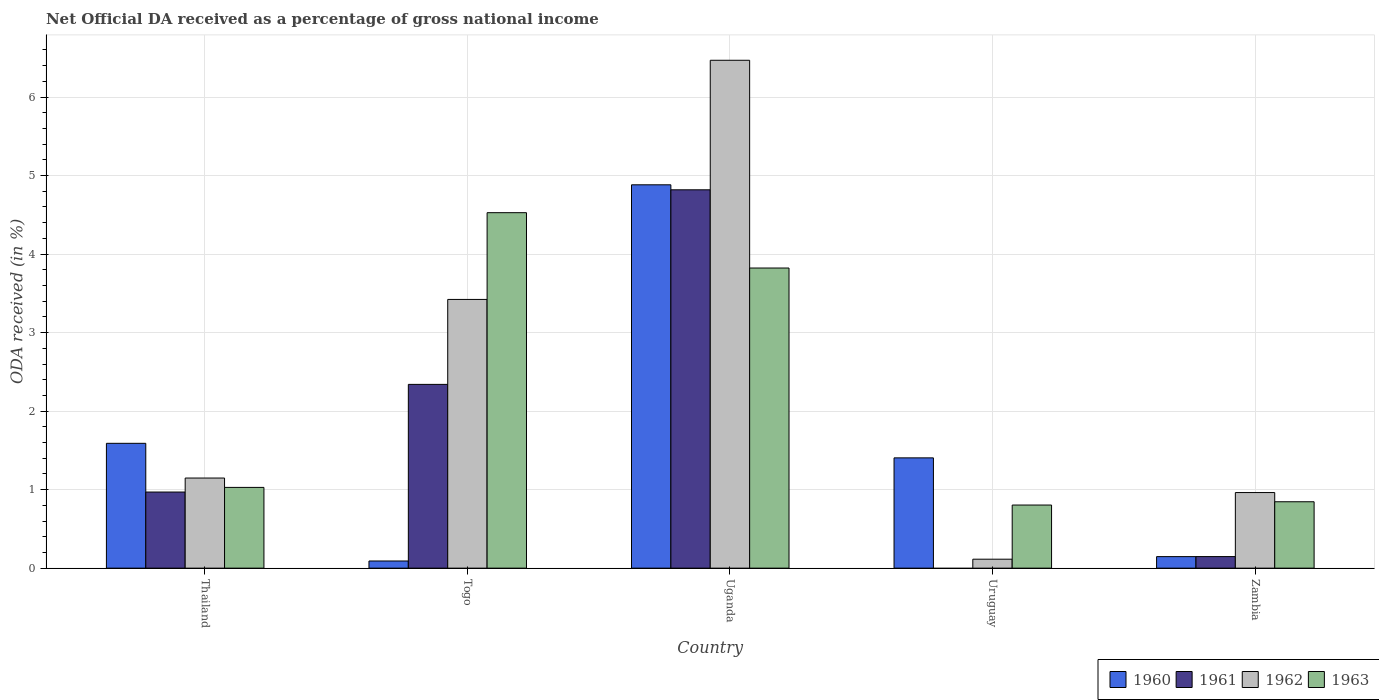How many different coloured bars are there?
Provide a short and direct response. 4. How many groups of bars are there?
Your answer should be very brief. 5. Are the number of bars on each tick of the X-axis equal?
Give a very brief answer. No. What is the label of the 5th group of bars from the left?
Give a very brief answer. Zambia. What is the net official DA received in 1963 in Uruguay?
Offer a very short reply. 0.8. Across all countries, what is the maximum net official DA received in 1961?
Your answer should be compact. 4.82. Across all countries, what is the minimum net official DA received in 1962?
Provide a short and direct response. 0.11. In which country was the net official DA received in 1960 maximum?
Keep it short and to the point. Uganda. What is the total net official DA received in 1963 in the graph?
Your answer should be very brief. 11.03. What is the difference between the net official DA received in 1963 in Togo and that in Uganda?
Your answer should be very brief. 0.71. What is the difference between the net official DA received in 1960 in Uganda and the net official DA received in 1962 in Thailand?
Offer a terse response. 3.73. What is the average net official DA received in 1960 per country?
Provide a short and direct response. 1.62. What is the difference between the net official DA received of/in 1960 and net official DA received of/in 1963 in Thailand?
Ensure brevity in your answer.  0.56. In how many countries, is the net official DA received in 1961 greater than 5.8 %?
Make the answer very short. 0. What is the ratio of the net official DA received in 1962 in Thailand to that in Uganda?
Your answer should be compact. 0.18. Is the net official DA received in 1962 in Thailand less than that in Uganda?
Offer a terse response. Yes. Is the difference between the net official DA received in 1960 in Togo and Uganda greater than the difference between the net official DA received in 1963 in Togo and Uganda?
Your response must be concise. No. What is the difference between the highest and the second highest net official DA received in 1960?
Offer a terse response. -3.29. What is the difference between the highest and the lowest net official DA received in 1963?
Offer a very short reply. 3.72. In how many countries, is the net official DA received in 1961 greater than the average net official DA received in 1961 taken over all countries?
Your response must be concise. 2. Is the sum of the net official DA received in 1960 in Thailand and Uganda greater than the maximum net official DA received in 1961 across all countries?
Provide a succinct answer. Yes. Are all the bars in the graph horizontal?
Your answer should be very brief. No. How many countries are there in the graph?
Offer a very short reply. 5. What is the difference between two consecutive major ticks on the Y-axis?
Provide a succinct answer. 1. Are the values on the major ticks of Y-axis written in scientific E-notation?
Provide a succinct answer. No. Does the graph contain grids?
Provide a short and direct response. Yes. How many legend labels are there?
Provide a succinct answer. 4. What is the title of the graph?
Keep it short and to the point. Net Official DA received as a percentage of gross national income. What is the label or title of the Y-axis?
Provide a short and direct response. ODA received (in %). What is the ODA received (in %) in 1960 in Thailand?
Provide a short and direct response. 1.59. What is the ODA received (in %) in 1961 in Thailand?
Offer a terse response. 0.97. What is the ODA received (in %) of 1962 in Thailand?
Offer a very short reply. 1.15. What is the ODA received (in %) in 1963 in Thailand?
Give a very brief answer. 1.03. What is the ODA received (in %) of 1960 in Togo?
Ensure brevity in your answer.  0.09. What is the ODA received (in %) of 1961 in Togo?
Your answer should be very brief. 2.34. What is the ODA received (in %) of 1962 in Togo?
Keep it short and to the point. 3.42. What is the ODA received (in %) of 1963 in Togo?
Give a very brief answer. 4.53. What is the ODA received (in %) of 1960 in Uganda?
Your answer should be compact. 4.88. What is the ODA received (in %) in 1961 in Uganda?
Provide a short and direct response. 4.82. What is the ODA received (in %) of 1962 in Uganda?
Offer a very short reply. 6.47. What is the ODA received (in %) in 1963 in Uganda?
Your answer should be very brief. 3.82. What is the ODA received (in %) in 1960 in Uruguay?
Your response must be concise. 1.4. What is the ODA received (in %) of 1961 in Uruguay?
Make the answer very short. 0. What is the ODA received (in %) of 1962 in Uruguay?
Ensure brevity in your answer.  0.11. What is the ODA received (in %) in 1963 in Uruguay?
Offer a terse response. 0.8. What is the ODA received (in %) in 1960 in Zambia?
Your answer should be compact. 0.15. What is the ODA received (in %) in 1961 in Zambia?
Your response must be concise. 0.15. What is the ODA received (in %) in 1962 in Zambia?
Ensure brevity in your answer.  0.96. What is the ODA received (in %) in 1963 in Zambia?
Offer a very short reply. 0.85. Across all countries, what is the maximum ODA received (in %) of 1960?
Provide a succinct answer. 4.88. Across all countries, what is the maximum ODA received (in %) in 1961?
Your answer should be compact. 4.82. Across all countries, what is the maximum ODA received (in %) in 1962?
Ensure brevity in your answer.  6.47. Across all countries, what is the maximum ODA received (in %) of 1963?
Provide a short and direct response. 4.53. Across all countries, what is the minimum ODA received (in %) in 1960?
Offer a terse response. 0.09. Across all countries, what is the minimum ODA received (in %) of 1962?
Offer a terse response. 0.11. Across all countries, what is the minimum ODA received (in %) in 1963?
Your answer should be compact. 0.8. What is the total ODA received (in %) of 1960 in the graph?
Keep it short and to the point. 8.12. What is the total ODA received (in %) of 1961 in the graph?
Your response must be concise. 8.28. What is the total ODA received (in %) of 1962 in the graph?
Ensure brevity in your answer.  12.12. What is the total ODA received (in %) in 1963 in the graph?
Ensure brevity in your answer.  11.03. What is the difference between the ODA received (in %) in 1960 in Thailand and that in Togo?
Your answer should be very brief. 1.5. What is the difference between the ODA received (in %) of 1961 in Thailand and that in Togo?
Keep it short and to the point. -1.37. What is the difference between the ODA received (in %) of 1962 in Thailand and that in Togo?
Provide a succinct answer. -2.27. What is the difference between the ODA received (in %) in 1963 in Thailand and that in Togo?
Provide a short and direct response. -3.5. What is the difference between the ODA received (in %) in 1960 in Thailand and that in Uganda?
Keep it short and to the point. -3.29. What is the difference between the ODA received (in %) in 1961 in Thailand and that in Uganda?
Offer a terse response. -3.85. What is the difference between the ODA received (in %) in 1962 in Thailand and that in Uganda?
Make the answer very short. -5.32. What is the difference between the ODA received (in %) in 1963 in Thailand and that in Uganda?
Provide a succinct answer. -2.79. What is the difference between the ODA received (in %) of 1960 in Thailand and that in Uruguay?
Your answer should be very brief. 0.19. What is the difference between the ODA received (in %) of 1962 in Thailand and that in Uruguay?
Your response must be concise. 1.03. What is the difference between the ODA received (in %) of 1963 in Thailand and that in Uruguay?
Make the answer very short. 0.22. What is the difference between the ODA received (in %) of 1960 in Thailand and that in Zambia?
Your answer should be compact. 1.44. What is the difference between the ODA received (in %) in 1961 in Thailand and that in Zambia?
Make the answer very short. 0.82. What is the difference between the ODA received (in %) of 1962 in Thailand and that in Zambia?
Make the answer very short. 0.18. What is the difference between the ODA received (in %) in 1963 in Thailand and that in Zambia?
Your answer should be compact. 0.18. What is the difference between the ODA received (in %) of 1960 in Togo and that in Uganda?
Your answer should be compact. -4.79. What is the difference between the ODA received (in %) in 1961 in Togo and that in Uganda?
Your answer should be compact. -2.48. What is the difference between the ODA received (in %) in 1962 in Togo and that in Uganda?
Offer a very short reply. -3.05. What is the difference between the ODA received (in %) in 1963 in Togo and that in Uganda?
Keep it short and to the point. 0.7. What is the difference between the ODA received (in %) in 1960 in Togo and that in Uruguay?
Your response must be concise. -1.31. What is the difference between the ODA received (in %) of 1962 in Togo and that in Uruguay?
Provide a short and direct response. 3.31. What is the difference between the ODA received (in %) of 1963 in Togo and that in Uruguay?
Your answer should be compact. 3.72. What is the difference between the ODA received (in %) in 1960 in Togo and that in Zambia?
Your answer should be compact. -0.06. What is the difference between the ODA received (in %) in 1961 in Togo and that in Zambia?
Keep it short and to the point. 2.19. What is the difference between the ODA received (in %) of 1962 in Togo and that in Zambia?
Your answer should be very brief. 2.46. What is the difference between the ODA received (in %) of 1963 in Togo and that in Zambia?
Your response must be concise. 3.68. What is the difference between the ODA received (in %) in 1960 in Uganda and that in Uruguay?
Give a very brief answer. 3.48. What is the difference between the ODA received (in %) in 1962 in Uganda and that in Uruguay?
Offer a very short reply. 6.35. What is the difference between the ODA received (in %) of 1963 in Uganda and that in Uruguay?
Ensure brevity in your answer.  3.02. What is the difference between the ODA received (in %) in 1960 in Uganda and that in Zambia?
Give a very brief answer. 4.74. What is the difference between the ODA received (in %) in 1961 in Uganda and that in Zambia?
Offer a very short reply. 4.67. What is the difference between the ODA received (in %) of 1962 in Uganda and that in Zambia?
Keep it short and to the point. 5.51. What is the difference between the ODA received (in %) of 1963 in Uganda and that in Zambia?
Provide a short and direct response. 2.98. What is the difference between the ODA received (in %) in 1960 in Uruguay and that in Zambia?
Make the answer very short. 1.26. What is the difference between the ODA received (in %) of 1962 in Uruguay and that in Zambia?
Make the answer very short. -0.85. What is the difference between the ODA received (in %) of 1963 in Uruguay and that in Zambia?
Your answer should be very brief. -0.04. What is the difference between the ODA received (in %) in 1960 in Thailand and the ODA received (in %) in 1961 in Togo?
Offer a very short reply. -0.75. What is the difference between the ODA received (in %) in 1960 in Thailand and the ODA received (in %) in 1962 in Togo?
Offer a terse response. -1.83. What is the difference between the ODA received (in %) of 1960 in Thailand and the ODA received (in %) of 1963 in Togo?
Make the answer very short. -2.94. What is the difference between the ODA received (in %) in 1961 in Thailand and the ODA received (in %) in 1962 in Togo?
Your answer should be compact. -2.45. What is the difference between the ODA received (in %) of 1961 in Thailand and the ODA received (in %) of 1963 in Togo?
Your response must be concise. -3.56. What is the difference between the ODA received (in %) of 1962 in Thailand and the ODA received (in %) of 1963 in Togo?
Offer a terse response. -3.38. What is the difference between the ODA received (in %) of 1960 in Thailand and the ODA received (in %) of 1961 in Uganda?
Make the answer very short. -3.23. What is the difference between the ODA received (in %) of 1960 in Thailand and the ODA received (in %) of 1962 in Uganda?
Give a very brief answer. -4.88. What is the difference between the ODA received (in %) in 1960 in Thailand and the ODA received (in %) in 1963 in Uganda?
Keep it short and to the point. -2.23. What is the difference between the ODA received (in %) in 1961 in Thailand and the ODA received (in %) in 1962 in Uganda?
Ensure brevity in your answer.  -5.5. What is the difference between the ODA received (in %) in 1961 in Thailand and the ODA received (in %) in 1963 in Uganda?
Provide a short and direct response. -2.85. What is the difference between the ODA received (in %) in 1962 in Thailand and the ODA received (in %) in 1963 in Uganda?
Offer a terse response. -2.67. What is the difference between the ODA received (in %) of 1960 in Thailand and the ODA received (in %) of 1962 in Uruguay?
Your answer should be very brief. 1.48. What is the difference between the ODA received (in %) in 1960 in Thailand and the ODA received (in %) in 1963 in Uruguay?
Ensure brevity in your answer.  0.79. What is the difference between the ODA received (in %) in 1961 in Thailand and the ODA received (in %) in 1962 in Uruguay?
Provide a succinct answer. 0.86. What is the difference between the ODA received (in %) in 1961 in Thailand and the ODA received (in %) in 1963 in Uruguay?
Ensure brevity in your answer.  0.17. What is the difference between the ODA received (in %) in 1962 in Thailand and the ODA received (in %) in 1963 in Uruguay?
Provide a succinct answer. 0.34. What is the difference between the ODA received (in %) in 1960 in Thailand and the ODA received (in %) in 1961 in Zambia?
Offer a very short reply. 1.44. What is the difference between the ODA received (in %) of 1960 in Thailand and the ODA received (in %) of 1962 in Zambia?
Give a very brief answer. 0.63. What is the difference between the ODA received (in %) of 1960 in Thailand and the ODA received (in %) of 1963 in Zambia?
Offer a terse response. 0.74. What is the difference between the ODA received (in %) of 1961 in Thailand and the ODA received (in %) of 1962 in Zambia?
Your response must be concise. 0.01. What is the difference between the ODA received (in %) in 1961 in Thailand and the ODA received (in %) in 1963 in Zambia?
Give a very brief answer. 0.12. What is the difference between the ODA received (in %) in 1962 in Thailand and the ODA received (in %) in 1963 in Zambia?
Offer a terse response. 0.3. What is the difference between the ODA received (in %) of 1960 in Togo and the ODA received (in %) of 1961 in Uganda?
Offer a terse response. -4.73. What is the difference between the ODA received (in %) in 1960 in Togo and the ODA received (in %) in 1962 in Uganda?
Give a very brief answer. -6.38. What is the difference between the ODA received (in %) of 1960 in Togo and the ODA received (in %) of 1963 in Uganda?
Provide a succinct answer. -3.73. What is the difference between the ODA received (in %) of 1961 in Togo and the ODA received (in %) of 1962 in Uganda?
Your answer should be compact. -4.13. What is the difference between the ODA received (in %) of 1961 in Togo and the ODA received (in %) of 1963 in Uganda?
Provide a short and direct response. -1.48. What is the difference between the ODA received (in %) of 1962 in Togo and the ODA received (in %) of 1963 in Uganda?
Ensure brevity in your answer.  -0.4. What is the difference between the ODA received (in %) of 1960 in Togo and the ODA received (in %) of 1962 in Uruguay?
Keep it short and to the point. -0.02. What is the difference between the ODA received (in %) in 1960 in Togo and the ODA received (in %) in 1963 in Uruguay?
Provide a succinct answer. -0.71. What is the difference between the ODA received (in %) of 1961 in Togo and the ODA received (in %) of 1962 in Uruguay?
Give a very brief answer. 2.23. What is the difference between the ODA received (in %) in 1961 in Togo and the ODA received (in %) in 1963 in Uruguay?
Give a very brief answer. 1.54. What is the difference between the ODA received (in %) of 1962 in Togo and the ODA received (in %) of 1963 in Uruguay?
Your answer should be compact. 2.62. What is the difference between the ODA received (in %) in 1960 in Togo and the ODA received (in %) in 1961 in Zambia?
Make the answer very short. -0.06. What is the difference between the ODA received (in %) of 1960 in Togo and the ODA received (in %) of 1962 in Zambia?
Give a very brief answer. -0.87. What is the difference between the ODA received (in %) of 1960 in Togo and the ODA received (in %) of 1963 in Zambia?
Your answer should be very brief. -0.75. What is the difference between the ODA received (in %) in 1961 in Togo and the ODA received (in %) in 1962 in Zambia?
Your response must be concise. 1.38. What is the difference between the ODA received (in %) of 1961 in Togo and the ODA received (in %) of 1963 in Zambia?
Offer a terse response. 1.5. What is the difference between the ODA received (in %) in 1962 in Togo and the ODA received (in %) in 1963 in Zambia?
Your answer should be very brief. 2.58. What is the difference between the ODA received (in %) in 1960 in Uganda and the ODA received (in %) in 1962 in Uruguay?
Offer a terse response. 4.77. What is the difference between the ODA received (in %) in 1960 in Uganda and the ODA received (in %) in 1963 in Uruguay?
Keep it short and to the point. 4.08. What is the difference between the ODA received (in %) of 1961 in Uganda and the ODA received (in %) of 1962 in Uruguay?
Give a very brief answer. 4.7. What is the difference between the ODA received (in %) of 1961 in Uganda and the ODA received (in %) of 1963 in Uruguay?
Provide a short and direct response. 4.01. What is the difference between the ODA received (in %) of 1962 in Uganda and the ODA received (in %) of 1963 in Uruguay?
Keep it short and to the point. 5.66. What is the difference between the ODA received (in %) in 1960 in Uganda and the ODA received (in %) in 1961 in Zambia?
Ensure brevity in your answer.  4.74. What is the difference between the ODA received (in %) in 1960 in Uganda and the ODA received (in %) in 1962 in Zambia?
Provide a succinct answer. 3.92. What is the difference between the ODA received (in %) of 1960 in Uganda and the ODA received (in %) of 1963 in Zambia?
Ensure brevity in your answer.  4.04. What is the difference between the ODA received (in %) in 1961 in Uganda and the ODA received (in %) in 1962 in Zambia?
Keep it short and to the point. 3.86. What is the difference between the ODA received (in %) of 1961 in Uganda and the ODA received (in %) of 1963 in Zambia?
Give a very brief answer. 3.97. What is the difference between the ODA received (in %) of 1962 in Uganda and the ODA received (in %) of 1963 in Zambia?
Ensure brevity in your answer.  5.62. What is the difference between the ODA received (in %) of 1960 in Uruguay and the ODA received (in %) of 1961 in Zambia?
Provide a succinct answer. 1.26. What is the difference between the ODA received (in %) in 1960 in Uruguay and the ODA received (in %) in 1962 in Zambia?
Your answer should be very brief. 0.44. What is the difference between the ODA received (in %) of 1960 in Uruguay and the ODA received (in %) of 1963 in Zambia?
Ensure brevity in your answer.  0.56. What is the difference between the ODA received (in %) in 1962 in Uruguay and the ODA received (in %) in 1963 in Zambia?
Your response must be concise. -0.73. What is the average ODA received (in %) in 1960 per country?
Give a very brief answer. 1.62. What is the average ODA received (in %) of 1961 per country?
Your response must be concise. 1.66. What is the average ODA received (in %) of 1962 per country?
Give a very brief answer. 2.42. What is the average ODA received (in %) in 1963 per country?
Your response must be concise. 2.21. What is the difference between the ODA received (in %) in 1960 and ODA received (in %) in 1961 in Thailand?
Offer a terse response. 0.62. What is the difference between the ODA received (in %) of 1960 and ODA received (in %) of 1962 in Thailand?
Make the answer very short. 0.44. What is the difference between the ODA received (in %) of 1960 and ODA received (in %) of 1963 in Thailand?
Ensure brevity in your answer.  0.56. What is the difference between the ODA received (in %) of 1961 and ODA received (in %) of 1962 in Thailand?
Ensure brevity in your answer.  -0.18. What is the difference between the ODA received (in %) in 1961 and ODA received (in %) in 1963 in Thailand?
Offer a terse response. -0.06. What is the difference between the ODA received (in %) of 1962 and ODA received (in %) of 1963 in Thailand?
Offer a very short reply. 0.12. What is the difference between the ODA received (in %) in 1960 and ODA received (in %) in 1961 in Togo?
Provide a succinct answer. -2.25. What is the difference between the ODA received (in %) of 1960 and ODA received (in %) of 1962 in Togo?
Your answer should be compact. -3.33. What is the difference between the ODA received (in %) of 1960 and ODA received (in %) of 1963 in Togo?
Provide a succinct answer. -4.44. What is the difference between the ODA received (in %) in 1961 and ODA received (in %) in 1962 in Togo?
Your answer should be compact. -1.08. What is the difference between the ODA received (in %) in 1961 and ODA received (in %) in 1963 in Togo?
Your response must be concise. -2.19. What is the difference between the ODA received (in %) in 1962 and ODA received (in %) in 1963 in Togo?
Provide a short and direct response. -1.1. What is the difference between the ODA received (in %) of 1960 and ODA received (in %) of 1961 in Uganda?
Offer a very short reply. 0.06. What is the difference between the ODA received (in %) of 1960 and ODA received (in %) of 1962 in Uganda?
Your answer should be very brief. -1.59. What is the difference between the ODA received (in %) of 1960 and ODA received (in %) of 1963 in Uganda?
Your answer should be very brief. 1.06. What is the difference between the ODA received (in %) in 1961 and ODA received (in %) in 1962 in Uganda?
Your answer should be compact. -1.65. What is the difference between the ODA received (in %) in 1961 and ODA received (in %) in 1963 in Uganda?
Ensure brevity in your answer.  1. What is the difference between the ODA received (in %) of 1962 and ODA received (in %) of 1963 in Uganda?
Provide a succinct answer. 2.65. What is the difference between the ODA received (in %) of 1960 and ODA received (in %) of 1962 in Uruguay?
Provide a short and direct response. 1.29. What is the difference between the ODA received (in %) in 1960 and ODA received (in %) in 1963 in Uruguay?
Your answer should be compact. 0.6. What is the difference between the ODA received (in %) in 1962 and ODA received (in %) in 1963 in Uruguay?
Offer a terse response. -0.69. What is the difference between the ODA received (in %) of 1960 and ODA received (in %) of 1961 in Zambia?
Your answer should be very brief. -0. What is the difference between the ODA received (in %) in 1960 and ODA received (in %) in 1962 in Zambia?
Ensure brevity in your answer.  -0.82. What is the difference between the ODA received (in %) of 1960 and ODA received (in %) of 1963 in Zambia?
Provide a short and direct response. -0.7. What is the difference between the ODA received (in %) in 1961 and ODA received (in %) in 1962 in Zambia?
Ensure brevity in your answer.  -0.82. What is the difference between the ODA received (in %) in 1961 and ODA received (in %) in 1963 in Zambia?
Make the answer very short. -0.7. What is the difference between the ODA received (in %) of 1962 and ODA received (in %) of 1963 in Zambia?
Ensure brevity in your answer.  0.12. What is the ratio of the ODA received (in %) in 1960 in Thailand to that in Togo?
Offer a terse response. 17.44. What is the ratio of the ODA received (in %) in 1961 in Thailand to that in Togo?
Ensure brevity in your answer.  0.41. What is the ratio of the ODA received (in %) in 1962 in Thailand to that in Togo?
Provide a short and direct response. 0.34. What is the ratio of the ODA received (in %) of 1963 in Thailand to that in Togo?
Make the answer very short. 0.23. What is the ratio of the ODA received (in %) in 1960 in Thailand to that in Uganda?
Offer a terse response. 0.33. What is the ratio of the ODA received (in %) in 1961 in Thailand to that in Uganda?
Your answer should be very brief. 0.2. What is the ratio of the ODA received (in %) of 1962 in Thailand to that in Uganda?
Your answer should be compact. 0.18. What is the ratio of the ODA received (in %) of 1963 in Thailand to that in Uganda?
Your answer should be compact. 0.27. What is the ratio of the ODA received (in %) of 1960 in Thailand to that in Uruguay?
Keep it short and to the point. 1.13. What is the ratio of the ODA received (in %) of 1962 in Thailand to that in Uruguay?
Provide a short and direct response. 10.06. What is the ratio of the ODA received (in %) of 1963 in Thailand to that in Uruguay?
Your answer should be compact. 1.28. What is the ratio of the ODA received (in %) of 1960 in Thailand to that in Zambia?
Keep it short and to the point. 10.82. What is the ratio of the ODA received (in %) of 1961 in Thailand to that in Zambia?
Give a very brief answer. 6.58. What is the ratio of the ODA received (in %) of 1962 in Thailand to that in Zambia?
Offer a terse response. 1.19. What is the ratio of the ODA received (in %) of 1963 in Thailand to that in Zambia?
Your answer should be compact. 1.22. What is the ratio of the ODA received (in %) in 1960 in Togo to that in Uganda?
Ensure brevity in your answer.  0.02. What is the ratio of the ODA received (in %) in 1961 in Togo to that in Uganda?
Your response must be concise. 0.49. What is the ratio of the ODA received (in %) in 1962 in Togo to that in Uganda?
Offer a very short reply. 0.53. What is the ratio of the ODA received (in %) of 1963 in Togo to that in Uganda?
Your response must be concise. 1.18. What is the ratio of the ODA received (in %) of 1960 in Togo to that in Uruguay?
Ensure brevity in your answer.  0.06. What is the ratio of the ODA received (in %) in 1962 in Togo to that in Uruguay?
Provide a short and direct response. 30.01. What is the ratio of the ODA received (in %) of 1963 in Togo to that in Uruguay?
Provide a short and direct response. 5.63. What is the ratio of the ODA received (in %) in 1960 in Togo to that in Zambia?
Provide a short and direct response. 0.62. What is the ratio of the ODA received (in %) in 1961 in Togo to that in Zambia?
Offer a terse response. 15.89. What is the ratio of the ODA received (in %) in 1962 in Togo to that in Zambia?
Your answer should be very brief. 3.55. What is the ratio of the ODA received (in %) in 1963 in Togo to that in Zambia?
Provide a short and direct response. 5.35. What is the ratio of the ODA received (in %) in 1960 in Uganda to that in Uruguay?
Provide a short and direct response. 3.48. What is the ratio of the ODA received (in %) in 1962 in Uganda to that in Uruguay?
Ensure brevity in your answer.  56.73. What is the ratio of the ODA received (in %) in 1963 in Uganda to that in Uruguay?
Your response must be concise. 4.76. What is the ratio of the ODA received (in %) in 1960 in Uganda to that in Zambia?
Your answer should be compact. 33.23. What is the ratio of the ODA received (in %) in 1961 in Uganda to that in Zambia?
Your response must be concise. 32.72. What is the ratio of the ODA received (in %) of 1962 in Uganda to that in Zambia?
Your response must be concise. 6.72. What is the ratio of the ODA received (in %) in 1963 in Uganda to that in Zambia?
Provide a succinct answer. 4.52. What is the ratio of the ODA received (in %) in 1960 in Uruguay to that in Zambia?
Offer a very short reply. 9.56. What is the ratio of the ODA received (in %) of 1962 in Uruguay to that in Zambia?
Make the answer very short. 0.12. What is the ratio of the ODA received (in %) of 1963 in Uruguay to that in Zambia?
Make the answer very short. 0.95. What is the difference between the highest and the second highest ODA received (in %) in 1960?
Keep it short and to the point. 3.29. What is the difference between the highest and the second highest ODA received (in %) in 1961?
Offer a terse response. 2.48. What is the difference between the highest and the second highest ODA received (in %) of 1962?
Your answer should be very brief. 3.05. What is the difference between the highest and the second highest ODA received (in %) in 1963?
Give a very brief answer. 0.7. What is the difference between the highest and the lowest ODA received (in %) of 1960?
Keep it short and to the point. 4.79. What is the difference between the highest and the lowest ODA received (in %) in 1961?
Provide a succinct answer. 4.82. What is the difference between the highest and the lowest ODA received (in %) in 1962?
Ensure brevity in your answer.  6.35. What is the difference between the highest and the lowest ODA received (in %) of 1963?
Provide a succinct answer. 3.72. 